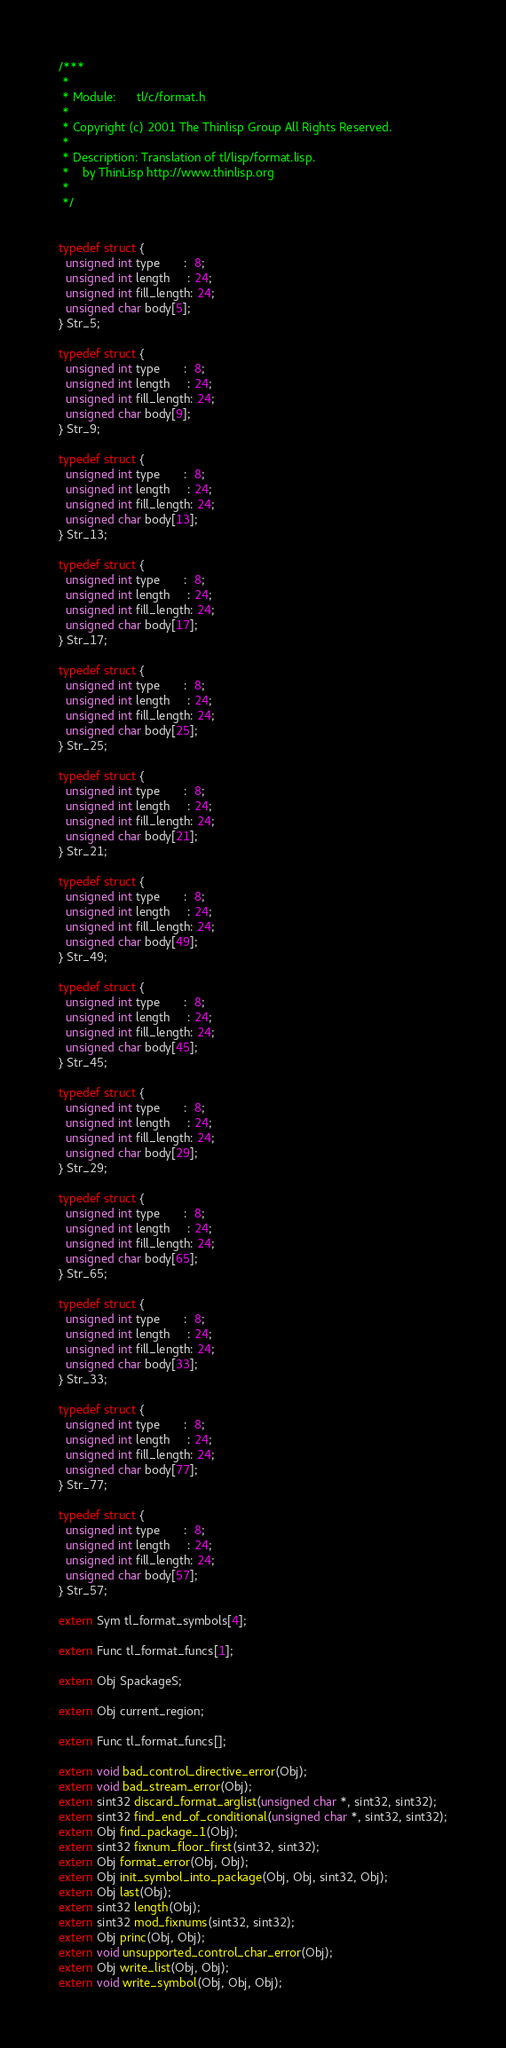Convert code to text. <code><loc_0><loc_0><loc_500><loc_500><_C_>/***
 *
 * Module:      tl/c/format.h
 *
 * Copyright (c) 2001 The Thinlisp Group All Rights Reserved.
 *
 * Description: Translation of tl/lisp/format.lisp.
 *    by ThinLisp http://www.thinlisp.org
 *
 */


typedef struct {
  unsigned int type       :  8;
  unsigned int length     : 24;
  unsigned int fill_length: 24;
  unsigned char body[5];
} Str_5;

typedef struct {
  unsigned int type       :  8;
  unsigned int length     : 24;
  unsigned int fill_length: 24;
  unsigned char body[9];
} Str_9;

typedef struct {
  unsigned int type       :  8;
  unsigned int length     : 24;
  unsigned int fill_length: 24;
  unsigned char body[13];
} Str_13;

typedef struct {
  unsigned int type       :  8;
  unsigned int length     : 24;
  unsigned int fill_length: 24;
  unsigned char body[17];
} Str_17;

typedef struct {
  unsigned int type       :  8;
  unsigned int length     : 24;
  unsigned int fill_length: 24;
  unsigned char body[25];
} Str_25;

typedef struct {
  unsigned int type       :  8;
  unsigned int length     : 24;
  unsigned int fill_length: 24;
  unsigned char body[21];
} Str_21;

typedef struct {
  unsigned int type       :  8;
  unsigned int length     : 24;
  unsigned int fill_length: 24;
  unsigned char body[49];
} Str_49;

typedef struct {
  unsigned int type       :  8;
  unsigned int length     : 24;
  unsigned int fill_length: 24;
  unsigned char body[45];
} Str_45;

typedef struct {
  unsigned int type       :  8;
  unsigned int length     : 24;
  unsigned int fill_length: 24;
  unsigned char body[29];
} Str_29;

typedef struct {
  unsigned int type       :  8;
  unsigned int length     : 24;
  unsigned int fill_length: 24;
  unsigned char body[65];
} Str_65;

typedef struct {
  unsigned int type       :  8;
  unsigned int length     : 24;
  unsigned int fill_length: 24;
  unsigned char body[33];
} Str_33;

typedef struct {
  unsigned int type       :  8;
  unsigned int length     : 24;
  unsigned int fill_length: 24;
  unsigned char body[77];
} Str_77;

typedef struct {
  unsigned int type       :  8;
  unsigned int length     : 24;
  unsigned int fill_length: 24;
  unsigned char body[57];
} Str_57;

extern Sym tl_format_symbols[4];

extern Func tl_format_funcs[1];

extern Obj SpackageS;

extern Obj current_region;

extern Func tl_format_funcs[];

extern void bad_control_directive_error(Obj);
extern void bad_stream_error(Obj);
extern sint32 discard_format_arglist(unsigned char *, sint32, sint32);
extern sint32 find_end_of_conditional(unsigned char *, sint32, sint32);
extern Obj find_package_1(Obj);
extern sint32 fixnum_floor_first(sint32, sint32);
extern Obj format_error(Obj, Obj);
extern Obj init_symbol_into_package(Obj, Obj, sint32, Obj);
extern Obj last(Obj);
extern sint32 length(Obj);
extern sint32 mod_fixnums(sint32, sint32);
extern Obj princ(Obj, Obj);
extern void unsupported_control_char_error(Obj);
extern Obj write_list(Obj, Obj);
extern void write_symbol(Obj, Obj, Obj);
</code> 